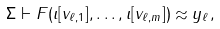Convert formula to latex. <formula><loc_0><loc_0><loc_500><loc_500>\Sigma \vdash F ( \imath [ v _ { \ell , 1 } ] , \dots , \imath [ v _ { \ell , m } ] ) \approx y _ { \ell } ,</formula> 